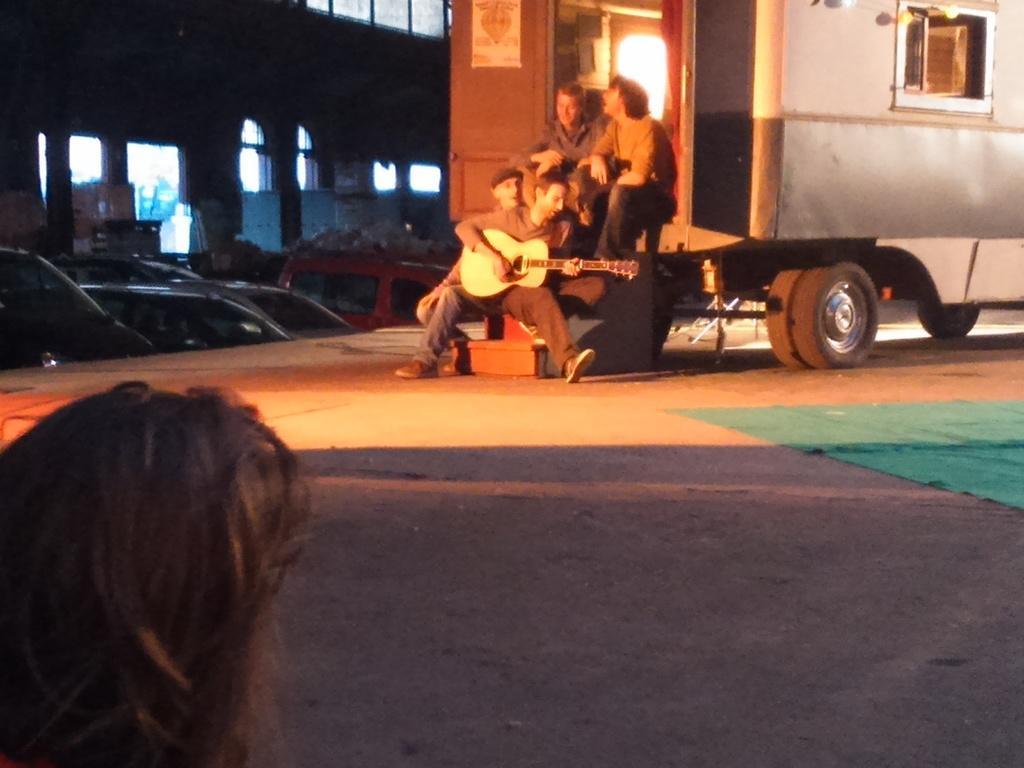Please provide a concise description of this image. This picture shows a truck and people seated on the stairs of the truck and a man playing guitar and we see few cars parked on the side 